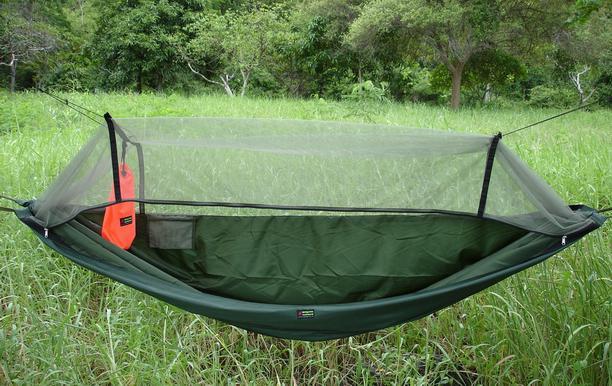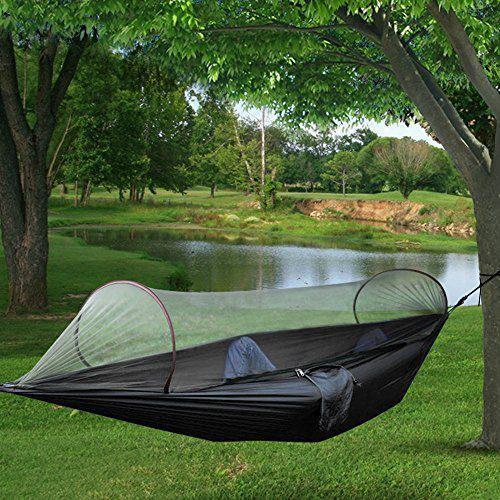The first image is the image on the left, the second image is the image on the right. Assess this claim about the two images: "A person can be seen in one image of a hanging hammock with netting cover.". Correct or not? Answer yes or no. Yes. 